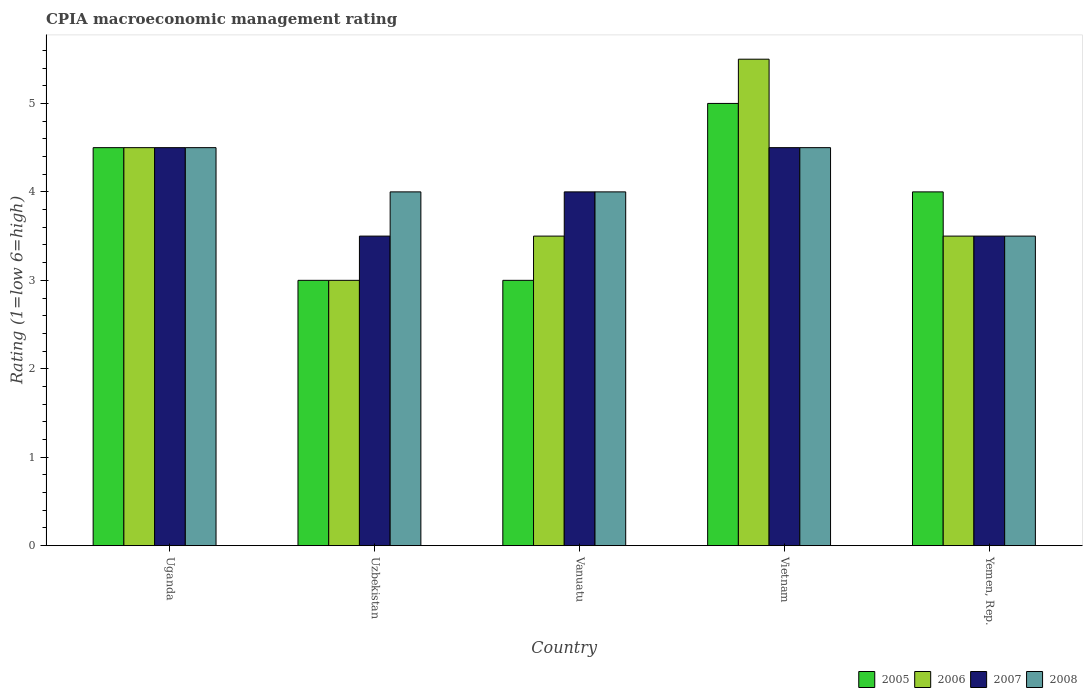How many different coloured bars are there?
Give a very brief answer. 4. Are the number of bars per tick equal to the number of legend labels?
Offer a very short reply. Yes. How many bars are there on the 3rd tick from the left?
Your answer should be very brief. 4. How many bars are there on the 1st tick from the right?
Offer a very short reply. 4. What is the label of the 2nd group of bars from the left?
Provide a succinct answer. Uzbekistan. What is the CPIA rating in 2006 in Yemen, Rep.?
Ensure brevity in your answer.  3.5. Across all countries, what is the maximum CPIA rating in 2008?
Give a very brief answer. 4.5. Across all countries, what is the minimum CPIA rating in 2008?
Offer a terse response. 3.5. In which country was the CPIA rating in 2005 maximum?
Provide a succinct answer. Vietnam. In which country was the CPIA rating in 2007 minimum?
Your answer should be compact. Uzbekistan. What is the difference between the CPIA rating in 2008 in Uzbekistan and that in Vietnam?
Your response must be concise. -0.5. What is the difference between the CPIA rating in 2005 in Uzbekistan and the CPIA rating in 2007 in Vietnam?
Offer a very short reply. -1.5. What is the average CPIA rating in 2006 per country?
Make the answer very short. 4. What is the difference between the CPIA rating of/in 2008 and CPIA rating of/in 2006 in Vietnam?
Your answer should be compact. -1. What is the ratio of the CPIA rating in 2007 in Vanuatu to that in Vietnam?
Your response must be concise. 0.89. What is the difference between the highest and the second highest CPIA rating in 2007?
Ensure brevity in your answer.  0.5. What is the difference between the highest and the lowest CPIA rating in 2007?
Give a very brief answer. 1. In how many countries, is the CPIA rating in 2006 greater than the average CPIA rating in 2006 taken over all countries?
Your answer should be very brief. 2. Is it the case that in every country, the sum of the CPIA rating in 2007 and CPIA rating in 2008 is greater than the sum of CPIA rating in 2006 and CPIA rating in 2005?
Your answer should be compact. No. What does the 4th bar from the left in Uzbekistan represents?
Your response must be concise. 2008. What does the 1st bar from the right in Vanuatu represents?
Your answer should be compact. 2008. How many bars are there?
Your answer should be compact. 20. Are all the bars in the graph horizontal?
Provide a short and direct response. No. Where does the legend appear in the graph?
Provide a succinct answer. Bottom right. How many legend labels are there?
Make the answer very short. 4. What is the title of the graph?
Provide a succinct answer. CPIA macroeconomic management rating. Does "2004" appear as one of the legend labels in the graph?
Your answer should be compact. No. What is the Rating (1=low 6=high) in 2005 in Uganda?
Keep it short and to the point. 4.5. What is the Rating (1=low 6=high) in 2007 in Uganda?
Provide a succinct answer. 4.5. What is the Rating (1=low 6=high) in 2008 in Uganda?
Ensure brevity in your answer.  4.5. What is the Rating (1=low 6=high) of 2007 in Uzbekistan?
Offer a terse response. 3.5. What is the Rating (1=low 6=high) in 2008 in Uzbekistan?
Offer a very short reply. 4. What is the Rating (1=low 6=high) in 2005 in Vanuatu?
Provide a succinct answer. 3. What is the Rating (1=low 6=high) of 2006 in Vanuatu?
Make the answer very short. 3.5. What is the Rating (1=low 6=high) of 2007 in Vanuatu?
Make the answer very short. 4. What is the Rating (1=low 6=high) in 2008 in Vanuatu?
Offer a terse response. 4. What is the Rating (1=low 6=high) in 2005 in Vietnam?
Your answer should be compact. 5. What is the Rating (1=low 6=high) of 2005 in Yemen, Rep.?
Give a very brief answer. 4. What is the Rating (1=low 6=high) of 2007 in Yemen, Rep.?
Offer a very short reply. 3.5. What is the Rating (1=low 6=high) of 2008 in Yemen, Rep.?
Provide a succinct answer. 3.5. Across all countries, what is the maximum Rating (1=low 6=high) in 2005?
Your response must be concise. 5. Across all countries, what is the maximum Rating (1=low 6=high) of 2006?
Give a very brief answer. 5.5. Across all countries, what is the maximum Rating (1=low 6=high) of 2008?
Provide a short and direct response. 4.5. Across all countries, what is the minimum Rating (1=low 6=high) of 2008?
Provide a short and direct response. 3.5. What is the total Rating (1=low 6=high) in 2006 in the graph?
Provide a short and direct response. 20. What is the total Rating (1=low 6=high) in 2007 in the graph?
Keep it short and to the point. 20. What is the difference between the Rating (1=low 6=high) in 2005 in Uganda and that in Uzbekistan?
Your answer should be very brief. 1.5. What is the difference between the Rating (1=low 6=high) of 2007 in Uganda and that in Uzbekistan?
Make the answer very short. 1. What is the difference between the Rating (1=low 6=high) in 2006 in Uganda and that in Vanuatu?
Make the answer very short. 1. What is the difference between the Rating (1=low 6=high) in 2008 in Uganda and that in Vanuatu?
Give a very brief answer. 0.5. What is the difference between the Rating (1=low 6=high) of 2005 in Uganda and that in Yemen, Rep.?
Your response must be concise. 0.5. What is the difference between the Rating (1=low 6=high) of 2007 in Uganda and that in Yemen, Rep.?
Ensure brevity in your answer.  1. What is the difference between the Rating (1=low 6=high) of 2008 in Uganda and that in Yemen, Rep.?
Your answer should be very brief. 1. What is the difference between the Rating (1=low 6=high) in 2005 in Uzbekistan and that in Vanuatu?
Your response must be concise. 0. What is the difference between the Rating (1=low 6=high) of 2006 in Uzbekistan and that in Vanuatu?
Give a very brief answer. -0.5. What is the difference between the Rating (1=low 6=high) in 2008 in Uzbekistan and that in Vanuatu?
Provide a succinct answer. 0. What is the difference between the Rating (1=low 6=high) in 2005 in Uzbekistan and that in Vietnam?
Make the answer very short. -2. What is the difference between the Rating (1=low 6=high) of 2006 in Uzbekistan and that in Vietnam?
Keep it short and to the point. -2.5. What is the difference between the Rating (1=low 6=high) in 2007 in Uzbekistan and that in Vietnam?
Your answer should be very brief. -1. What is the difference between the Rating (1=low 6=high) of 2005 in Uzbekistan and that in Yemen, Rep.?
Provide a short and direct response. -1. What is the difference between the Rating (1=low 6=high) of 2005 in Vanuatu and that in Vietnam?
Your answer should be very brief. -2. What is the difference between the Rating (1=low 6=high) of 2006 in Vanuatu and that in Vietnam?
Keep it short and to the point. -2. What is the difference between the Rating (1=low 6=high) of 2005 in Vanuatu and that in Yemen, Rep.?
Make the answer very short. -1. What is the difference between the Rating (1=low 6=high) of 2007 in Vanuatu and that in Yemen, Rep.?
Ensure brevity in your answer.  0.5. What is the difference between the Rating (1=low 6=high) in 2008 in Vanuatu and that in Yemen, Rep.?
Offer a very short reply. 0.5. What is the difference between the Rating (1=low 6=high) of 2005 in Vietnam and that in Yemen, Rep.?
Provide a short and direct response. 1. What is the difference between the Rating (1=low 6=high) of 2007 in Vietnam and that in Yemen, Rep.?
Provide a succinct answer. 1. What is the difference between the Rating (1=low 6=high) in 2008 in Vietnam and that in Yemen, Rep.?
Offer a terse response. 1. What is the difference between the Rating (1=low 6=high) in 2005 in Uganda and the Rating (1=low 6=high) in 2008 in Uzbekistan?
Ensure brevity in your answer.  0.5. What is the difference between the Rating (1=low 6=high) of 2006 in Uganda and the Rating (1=low 6=high) of 2007 in Uzbekistan?
Ensure brevity in your answer.  1. What is the difference between the Rating (1=low 6=high) in 2006 in Uganda and the Rating (1=low 6=high) in 2008 in Uzbekistan?
Provide a short and direct response. 0.5. What is the difference between the Rating (1=low 6=high) in 2005 in Uganda and the Rating (1=low 6=high) in 2008 in Vanuatu?
Your answer should be compact. 0.5. What is the difference between the Rating (1=low 6=high) of 2006 in Uganda and the Rating (1=low 6=high) of 2008 in Vanuatu?
Offer a very short reply. 0.5. What is the difference between the Rating (1=low 6=high) in 2007 in Uganda and the Rating (1=low 6=high) in 2008 in Vanuatu?
Provide a succinct answer. 0.5. What is the difference between the Rating (1=low 6=high) in 2007 in Uganda and the Rating (1=low 6=high) in 2008 in Yemen, Rep.?
Make the answer very short. 1. What is the difference between the Rating (1=low 6=high) of 2005 in Uzbekistan and the Rating (1=low 6=high) of 2006 in Vanuatu?
Your response must be concise. -0.5. What is the difference between the Rating (1=low 6=high) of 2006 in Uzbekistan and the Rating (1=low 6=high) of 2007 in Vanuatu?
Your response must be concise. -1. What is the difference between the Rating (1=low 6=high) in 2007 in Uzbekistan and the Rating (1=low 6=high) in 2008 in Vanuatu?
Your response must be concise. -0.5. What is the difference between the Rating (1=low 6=high) in 2005 in Uzbekistan and the Rating (1=low 6=high) in 2006 in Vietnam?
Offer a very short reply. -2.5. What is the difference between the Rating (1=low 6=high) in 2006 in Uzbekistan and the Rating (1=low 6=high) in 2007 in Vietnam?
Make the answer very short. -1.5. What is the difference between the Rating (1=low 6=high) of 2006 in Uzbekistan and the Rating (1=low 6=high) of 2008 in Vietnam?
Your answer should be compact. -1.5. What is the difference between the Rating (1=low 6=high) of 2006 in Uzbekistan and the Rating (1=low 6=high) of 2007 in Yemen, Rep.?
Your answer should be compact. -0.5. What is the difference between the Rating (1=low 6=high) of 2006 in Uzbekistan and the Rating (1=low 6=high) of 2008 in Yemen, Rep.?
Keep it short and to the point. -0.5. What is the difference between the Rating (1=low 6=high) in 2006 in Vanuatu and the Rating (1=low 6=high) in 2008 in Vietnam?
Offer a terse response. -1. What is the difference between the Rating (1=low 6=high) of 2006 in Vanuatu and the Rating (1=low 6=high) of 2007 in Yemen, Rep.?
Your answer should be compact. 0. What is the difference between the Rating (1=low 6=high) in 2006 in Vanuatu and the Rating (1=low 6=high) in 2008 in Yemen, Rep.?
Your answer should be compact. 0. What is the difference between the Rating (1=low 6=high) in 2005 in Vietnam and the Rating (1=low 6=high) in 2006 in Yemen, Rep.?
Offer a very short reply. 1.5. What is the difference between the Rating (1=low 6=high) of 2005 in Vietnam and the Rating (1=low 6=high) of 2008 in Yemen, Rep.?
Your response must be concise. 1.5. What is the difference between the Rating (1=low 6=high) of 2006 in Vietnam and the Rating (1=low 6=high) of 2008 in Yemen, Rep.?
Give a very brief answer. 2. What is the difference between the Rating (1=low 6=high) of 2007 in Vietnam and the Rating (1=low 6=high) of 2008 in Yemen, Rep.?
Provide a short and direct response. 1. What is the average Rating (1=low 6=high) in 2006 per country?
Offer a very short reply. 4. What is the difference between the Rating (1=low 6=high) in 2005 and Rating (1=low 6=high) in 2006 in Uganda?
Give a very brief answer. 0. What is the difference between the Rating (1=low 6=high) in 2005 and Rating (1=low 6=high) in 2007 in Uganda?
Your answer should be very brief. 0. What is the difference between the Rating (1=low 6=high) of 2006 and Rating (1=low 6=high) of 2007 in Uganda?
Keep it short and to the point. 0. What is the difference between the Rating (1=low 6=high) of 2007 and Rating (1=low 6=high) of 2008 in Uganda?
Make the answer very short. 0. What is the difference between the Rating (1=low 6=high) of 2005 and Rating (1=low 6=high) of 2006 in Uzbekistan?
Offer a very short reply. 0. What is the difference between the Rating (1=low 6=high) in 2005 and Rating (1=low 6=high) in 2006 in Vanuatu?
Provide a succinct answer. -0.5. What is the difference between the Rating (1=low 6=high) of 2005 and Rating (1=low 6=high) of 2007 in Vanuatu?
Provide a short and direct response. -1. What is the difference between the Rating (1=low 6=high) in 2005 and Rating (1=low 6=high) in 2008 in Vanuatu?
Your answer should be compact. -1. What is the difference between the Rating (1=low 6=high) of 2006 and Rating (1=low 6=high) of 2007 in Vanuatu?
Ensure brevity in your answer.  -0.5. What is the difference between the Rating (1=low 6=high) of 2005 and Rating (1=low 6=high) of 2006 in Vietnam?
Your answer should be compact. -0.5. What is the difference between the Rating (1=low 6=high) in 2005 and Rating (1=low 6=high) in 2008 in Vietnam?
Ensure brevity in your answer.  0.5. What is the difference between the Rating (1=low 6=high) of 2006 and Rating (1=low 6=high) of 2008 in Vietnam?
Provide a succinct answer. 1. What is the difference between the Rating (1=low 6=high) in 2005 and Rating (1=low 6=high) in 2008 in Yemen, Rep.?
Offer a very short reply. 0.5. What is the difference between the Rating (1=low 6=high) of 2007 and Rating (1=low 6=high) of 2008 in Yemen, Rep.?
Provide a succinct answer. 0. What is the ratio of the Rating (1=low 6=high) in 2008 in Uganda to that in Uzbekistan?
Offer a terse response. 1.12. What is the ratio of the Rating (1=low 6=high) in 2005 in Uganda to that in Vanuatu?
Offer a very short reply. 1.5. What is the ratio of the Rating (1=low 6=high) of 2005 in Uganda to that in Vietnam?
Provide a succinct answer. 0.9. What is the ratio of the Rating (1=low 6=high) in 2006 in Uganda to that in Vietnam?
Ensure brevity in your answer.  0.82. What is the ratio of the Rating (1=low 6=high) in 2005 in Uganda to that in Yemen, Rep.?
Offer a very short reply. 1.12. What is the ratio of the Rating (1=low 6=high) in 2006 in Uganda to that in Yemen, Rep.?
Provide a succinct answer. 1.29. What is the ratio of the Rating (1=low 6=high) of 2007 in Uganda to that in Yemen, Rep.?
Offer a very short reply. 1.29. What is the ratio of the Rating (1=low 6=high) in 2005 in Uzbekistan to that in Vanuatu?
Make the answer very short. 1. What is the ratio of the Rating (1=low 6=high) of 2006 in Uzbekistan to that in Vanuatu?
Keep it short and to the point. 0.86. What is the ratio of the Rating (1=low 6=high) in 2008 in Uzbekistan to that in Vanuatu?
Your response must be concise. 1. What is the ratio of the Rating (1=low 6=high) in 2005 in Uzbekistan to that in Vietnam?
Offer a very short reply. 0.6. What is the ratio of the Rating (1=low 6=high) in 2006 in Uzbekistan to that in Vietnam?
Your answer should be compact. 0.55. What is the ratio of the Rating (1=low 6=high) in 2007 in Uzbekistan to that in Vietnam?
Keep it short and to the point. 0.78. What is the ratio of the Rating (1=low 6=high) in 2008 in Uzbekistan to that in Vietnam?
Offer a terse response. 0.89. What is the ratio of the Rating (1=low 6=high) in 2005 in Uzbekistan to that in Yemen, Rep.?
Make the answer very short. 0.75. What is the ratio of the Rating (1=low 6=high) in 2006 in Uzbekistan to that in Yemen, Rep.?
Provide a short and direct response. 0.86. What is the ratio of the Rating (1=low 6=high) of 2005 in Vanuatu to that in Vietnam?
Offer a very short reply. 0.6. What is the ratio of the Rating (1=low 6=high) in 2006 in Vanuatu to that in Vietnam?
Offer a terse response. 0.64. What is the ratio of the Rating (1=low 6=high) of 2007 in Vanuatu to that in Vietnam?
Provide a short and direct response. 0.89. What is the ratio of the Rating (1=low 6=high) in 2008 in Vanuatu to that in Vietnam?
Keep it short and to the point. 0.89. What is the ratio of the Rating (1=low 6=high) of 2005 in Vanuatu to that in Yemen, Rep.?
Provide a succinct answer. 0.75. What is the ratio of the Rating (1=low 6=high) of 2006 in Vanuatu to that in Yemen, Rep.?
Keep it short and to the point. 1. What is the ratio of the Rating (1=low 6=high) of 2006 in Vietnam to that in Yemen, Rep.?
Your answer should be compact. 1.57. What is the difference between the highest and the second highest Rating (1=low 6=high) in 2005?
Make the answer very short. 0.5. What is the difference between the highest and the second highest Rating (1=low 6=high) of 2006?
Provide a succinct answer. 1. What is the difference between the highest and the second highest Rating (1=low 6=high) of 2008?
Ensure brevity in your answer.  0. What is the difference between the highest and the lowest Rating (1=low 6=high) of 2006?
Your answer should be very brief. 2.5. What is the difference between the highest and the lowest Rating (1=low 6=high) in 2007?
Offer a terse response. 1. 